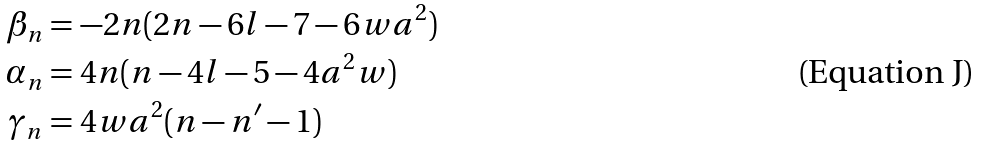<formula> <loc_0><loc_0><loc_500><loc_500>\beta _ { n } & = - 2 n ( 2 n - 6 l - 7 - 6 w a ^ { 2 } ) \\ \alpha _ { n } & = 4 n ( n - 4 l - 5 - 4 a ^ { 2 } w ) \\ \gamma _ { n } & = 4 w a ^ { 2 } ( n - n ^ { \prime } - 1 )</formula> 